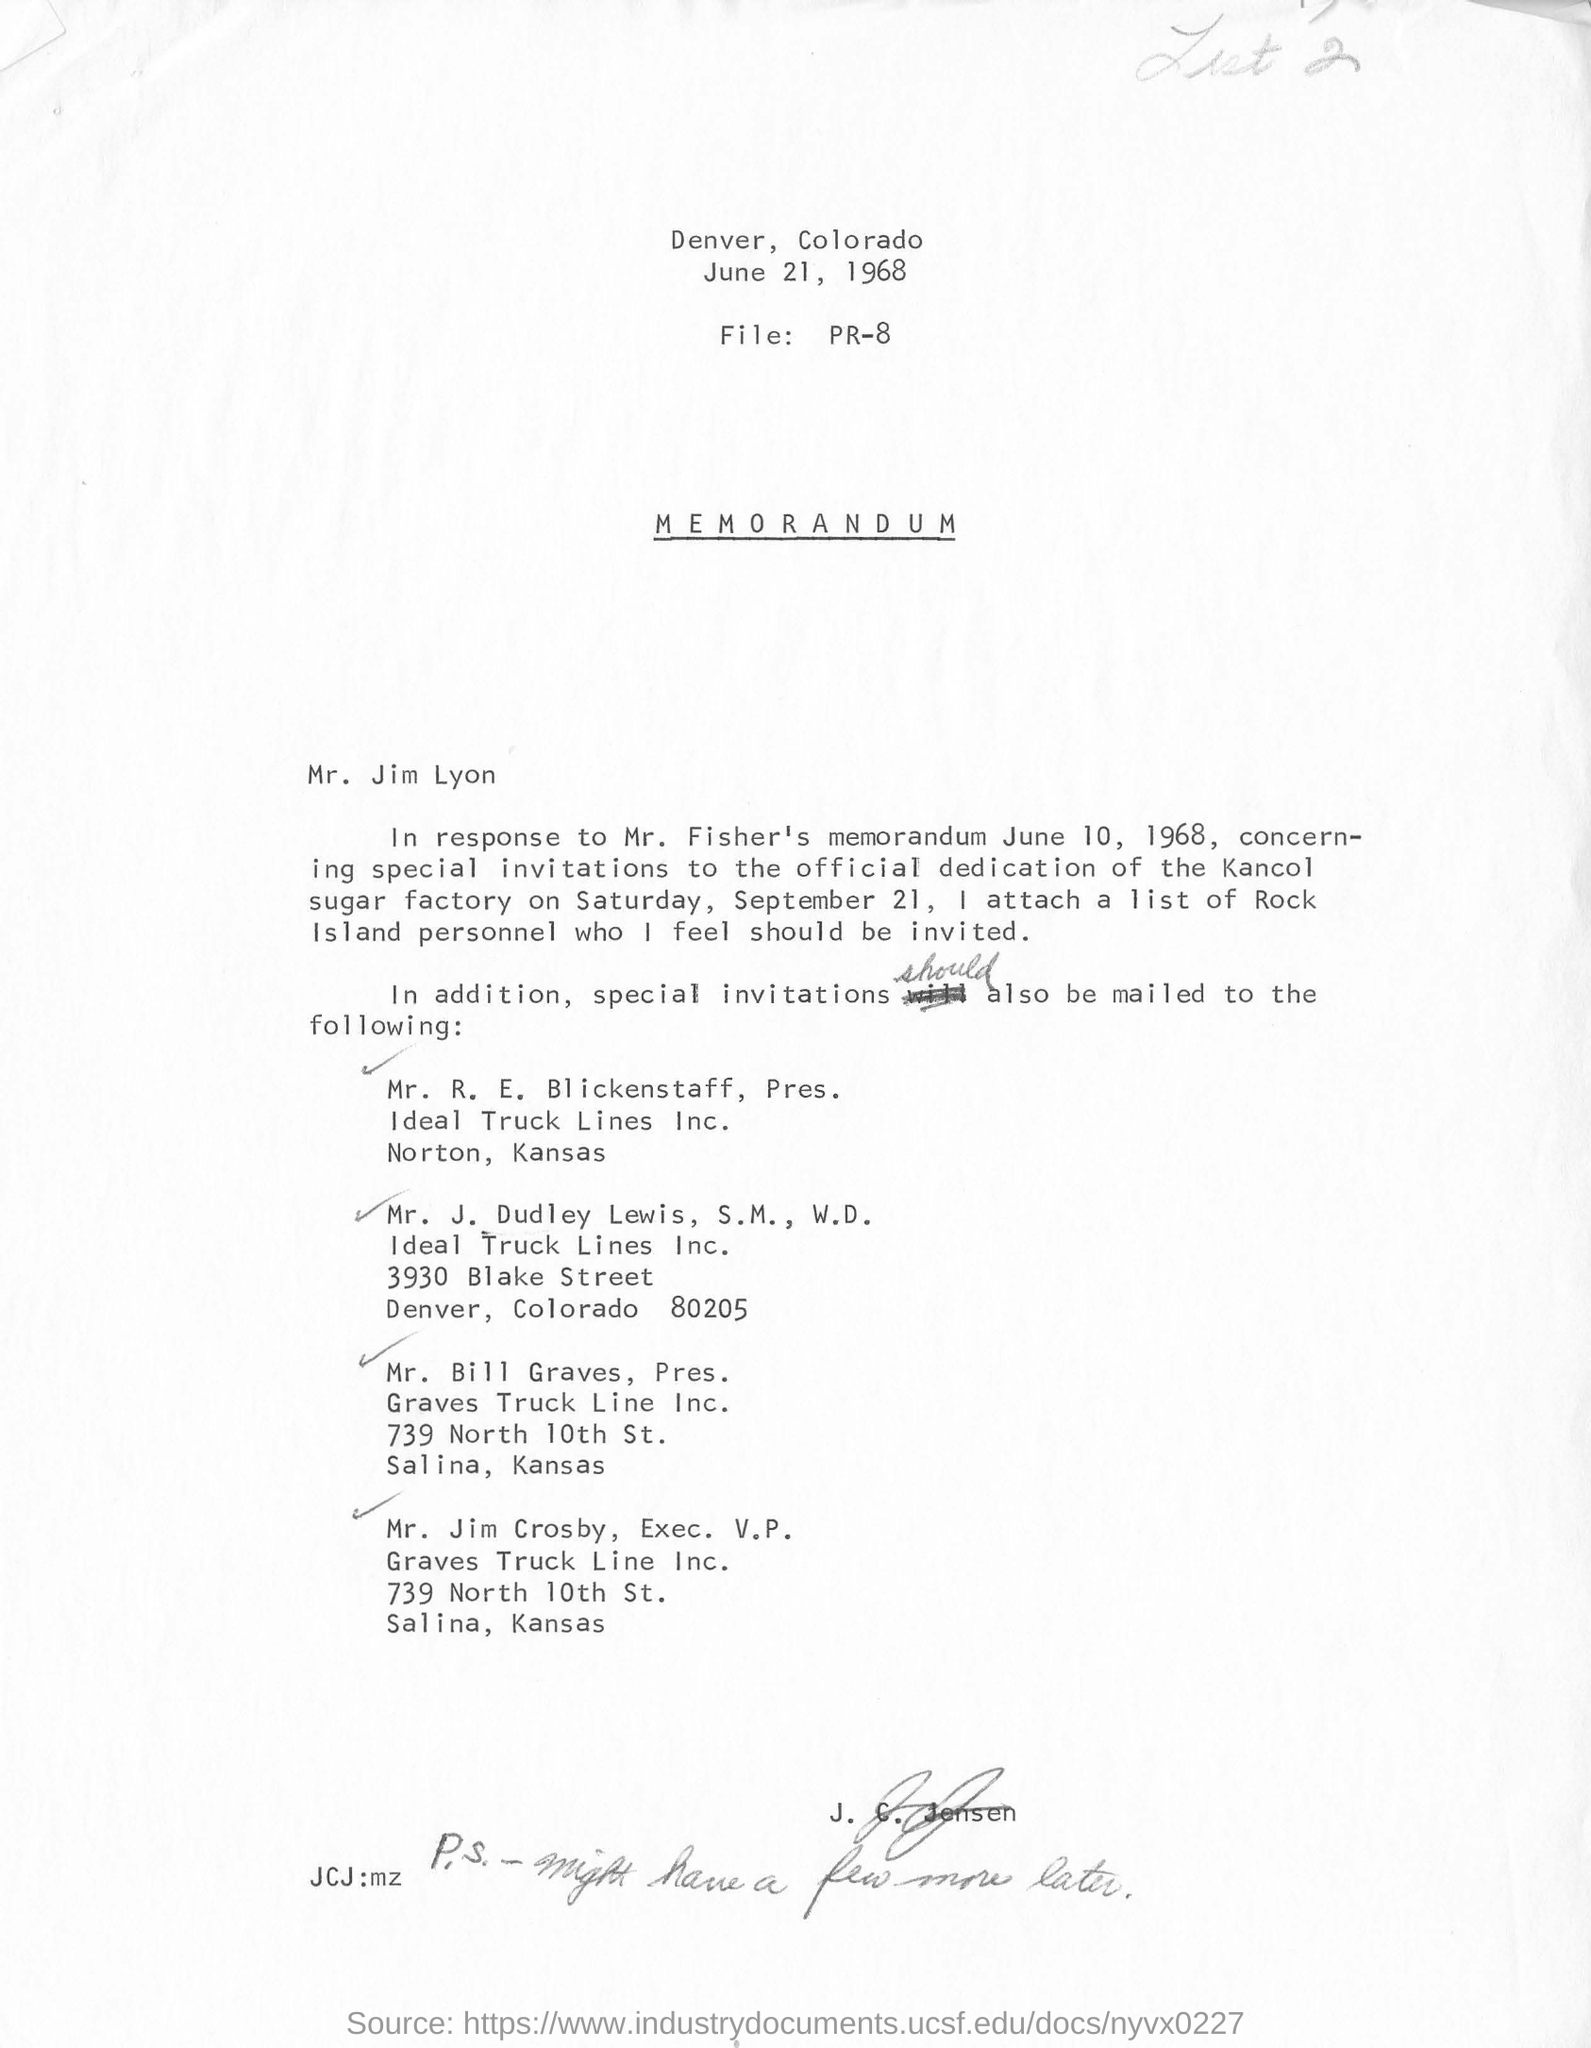Where is denver located?
Give a very brief answer. Colorado. What is the date at the top of the page?
Your answer should be compact. June 21, 1968. 